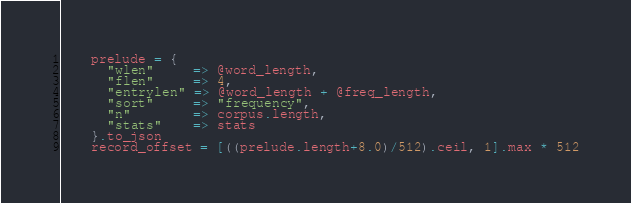<code> <loc_0><loc_0><loc_500><loc_500><_Ruby_>    prelude = {
      "wlen"     => @word_length,
      "flen"     => 4,
      "entrylen" => @word_length + @freq_length,
      "sort"     => "frequency",
      "n"        => corpus.length,
      "stats"    => stats
    }.to_json
    record_offset = [((prelude.length+8.0)/512).ceil, 1].max * 512</code> 